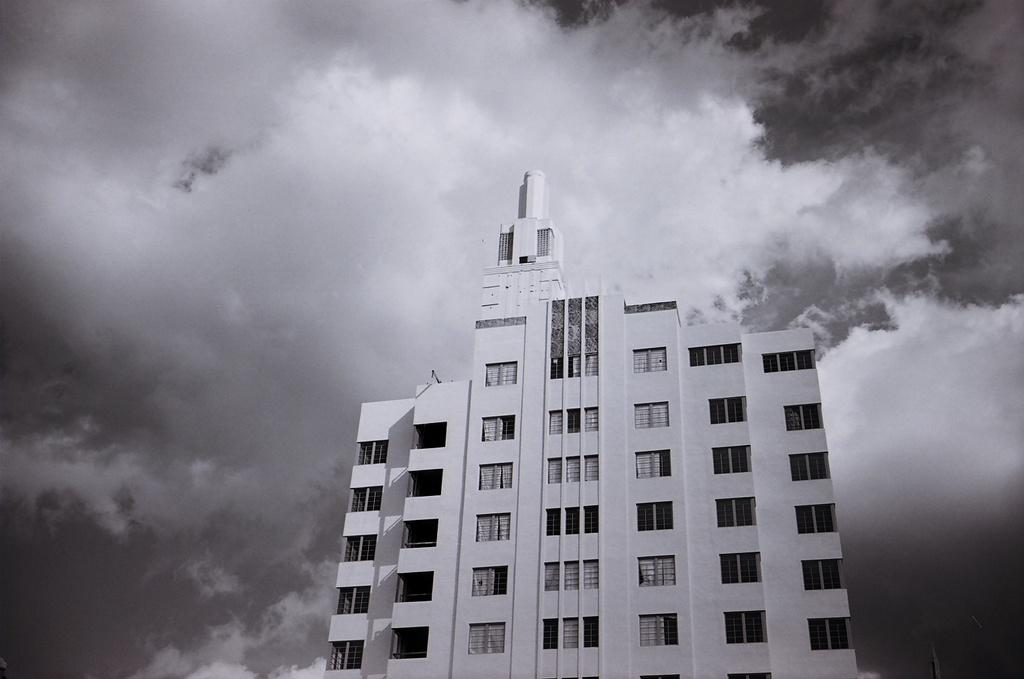What is the main subject of the picture? The main subject of the picture is a building. What can be seen in the background of the picture? The sky is visible in the background of the picture. What is the color scheme of the picture? The picture is black and white in color. Can you tell me how many docks are visible in the picture? There are no docks present in the picture; it features a building and the sky. What type of light source is illuminating the building in the picture? There is no specific light source mentioned or visible in the picture, as it is black and white. 